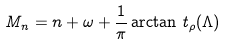<formula> <loc_0><loc_0><loc_500><loc_500>M _ { n } = n + \omega + \frac { 1 } { \pi } \arctan \, t _ { \rho } ( \Lambda )</formula> 